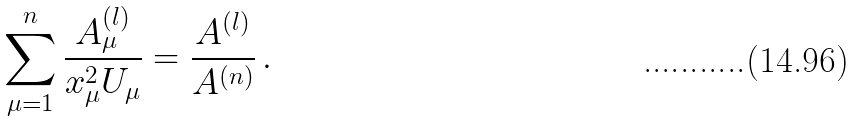<formula> <loc_0><loc_0><loc_500><loc_500>\sum _ { \mu = 1 } ^ { n } \frac { A _ { \mu } ^ { ( l ) } } { x _ { \mu } ^ { 2 } U _ { \mu } } = \frac { A ^ { ( l ) } } { A ^ { ( n ) } } \, .</formula> 